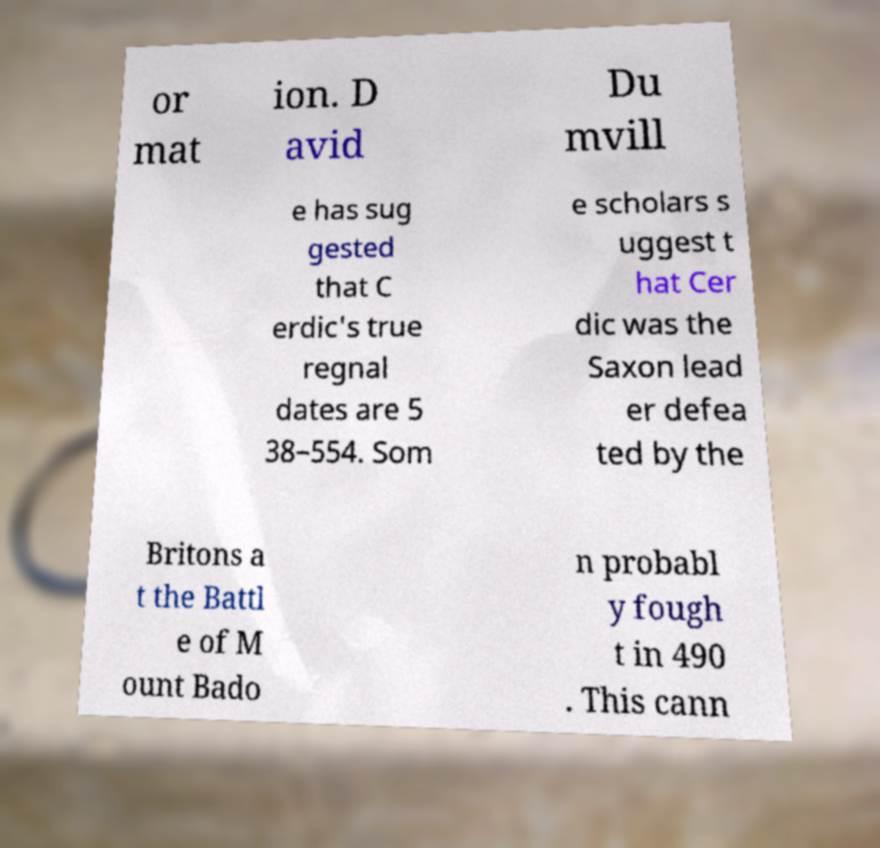Could you assist in decoding the text presented in this image and type it out clearly? or mat ion. D avid Du mvill e has sug gested that C erdic's true regnal dates are 5 38–554. Som e scholars s uggest t hat Cer dic was the Saxon lead er defea ted by the Britons a t the Battl e of M ount Bado n probabl y fough t in 490 . This cann 